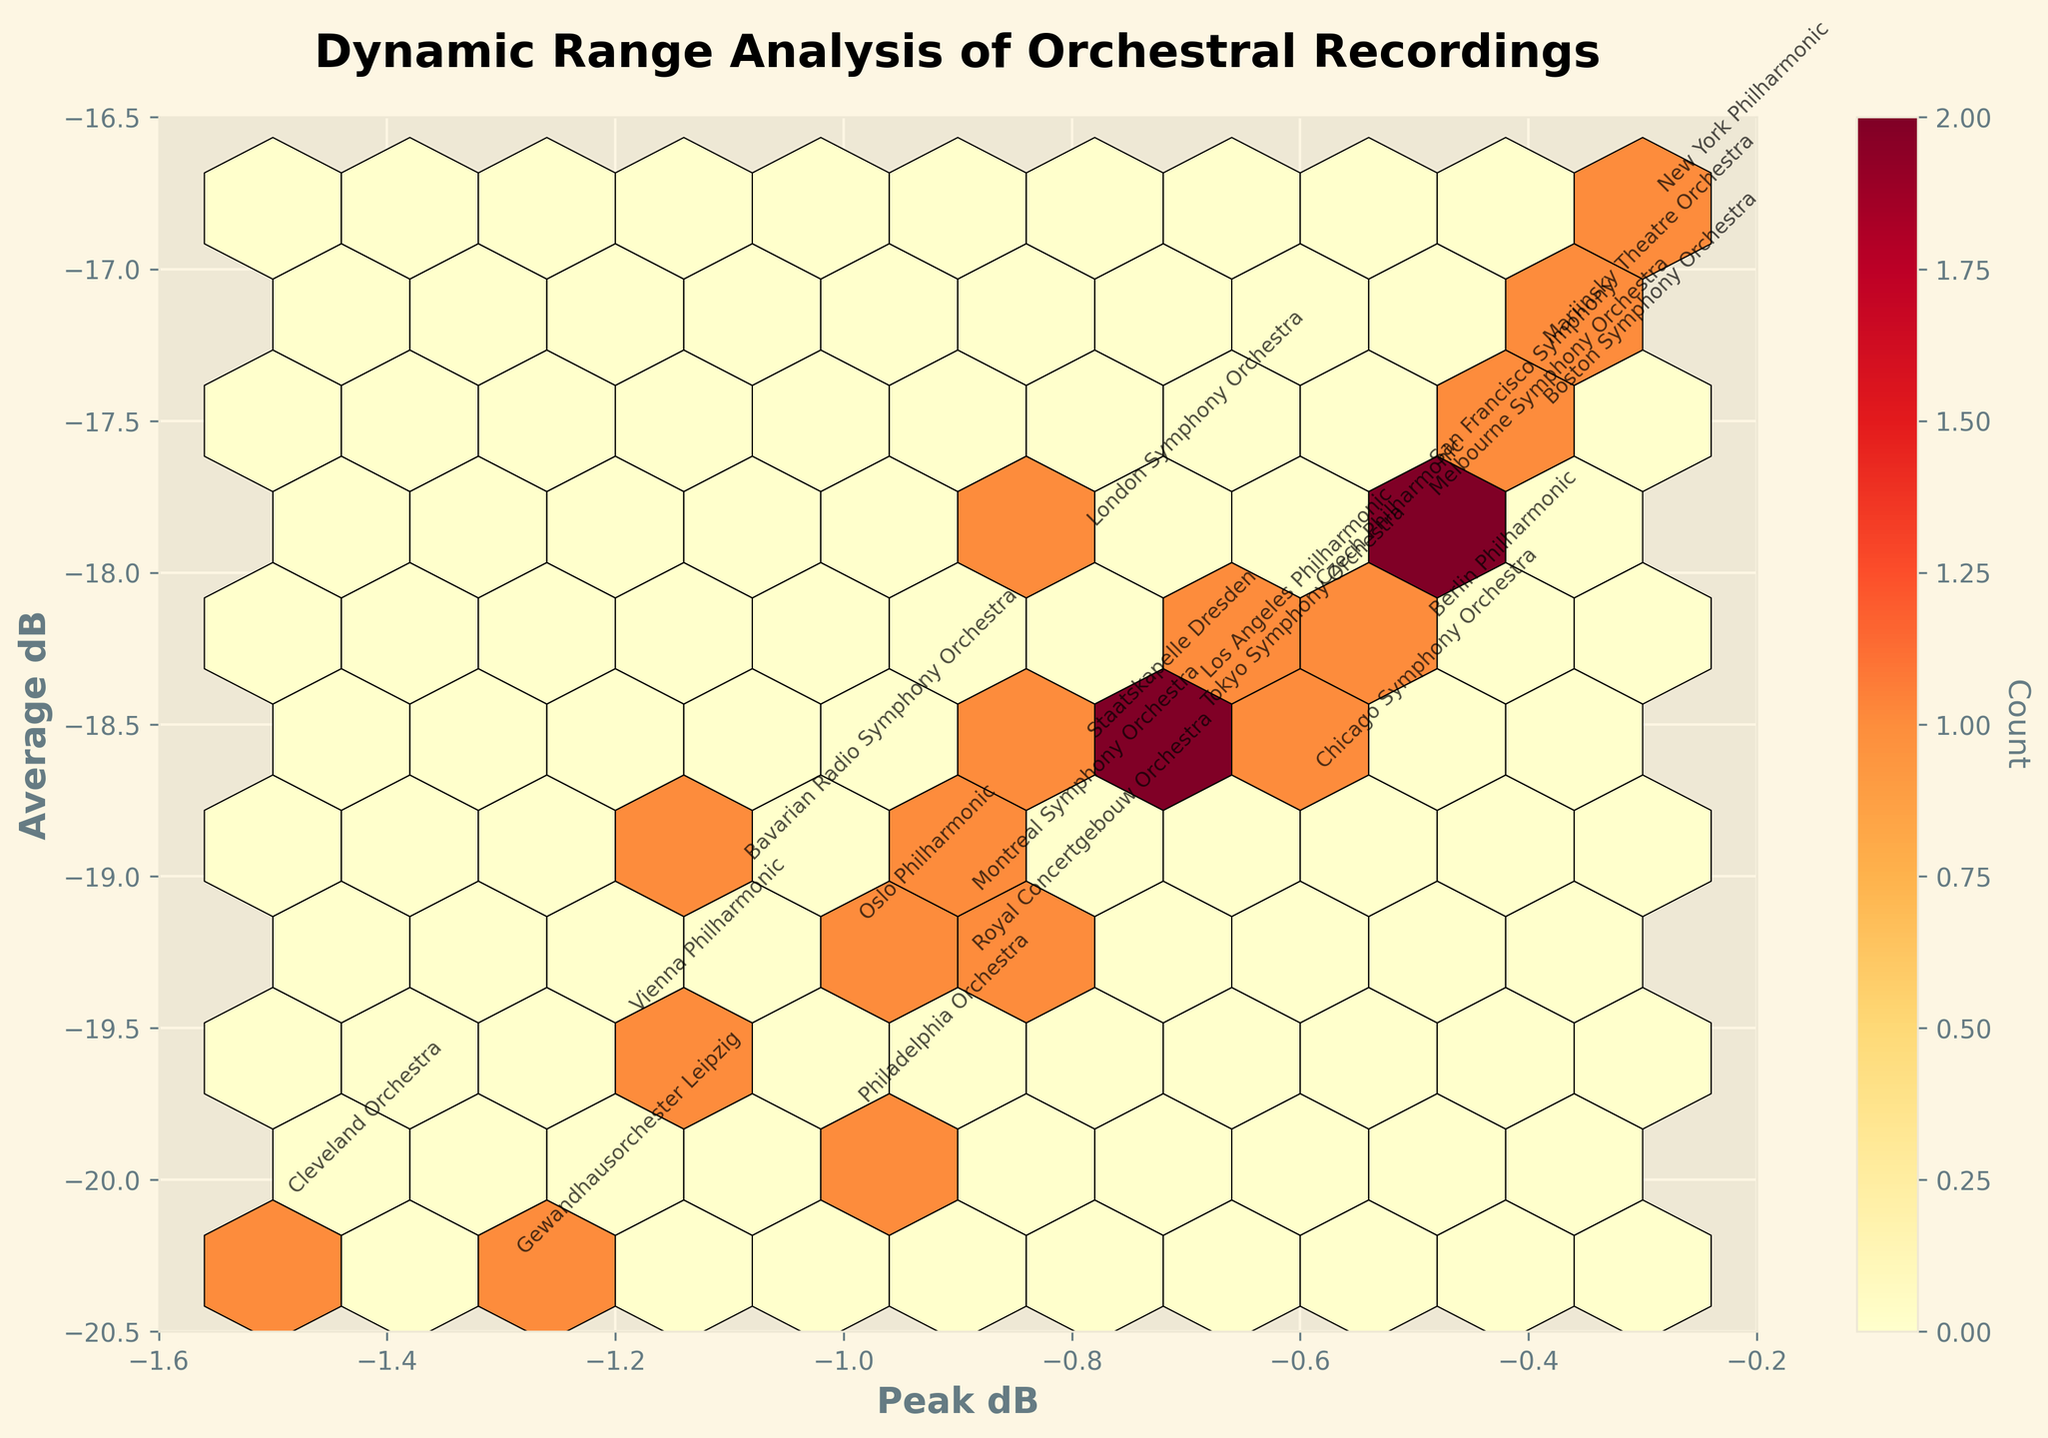What is the title of the Hexbin Plot? The title of the plot is typically located at the top in a larger font size compared to other text elements. It's usually a brief description of what the plot represents.
Answer: Dynamic Range Analysis of Orchestral Recordings What are the x-axis and y-axis labels? Axis labels are located along the horizontal and vertical axes of the plot and provide context for the data being displayed. The x-axis label is usually along the bottom, and the y-axis label is along the left side.
Answer: The x-axis label is 'Peak dB', and the y-axis label is 'Average dB' Which orchestra has the lowest Peak dB value? By examining the plot, you look for the data point that is farthest to the left, indicating the lowest Peak dB value. The orchestra name is typically annotated close to the data point.
Answer: Cleveland Orchestra What is the color range indicative of on this Hexbin Plot? Hexagon color in a Hexbin Plot generally represents the density of data points within that bin. By observing the color gradient and its corresponding color bar, you can interpret the density ranges.
Answer: It indicates the count of data points in each bin How many hexagons have the highest color intensity and what does this intensity represent? By examining the plotted hexagons and cross-referencing the most intense colors with the color bar, you can count the number of hexagons that share this intensity. Higher intensity colors typically represent higher data densities.
Answer: The number of hexagons and this intensity represent the highest density of data points being relatively rare, most likely 1 Which orchestra has the highest Average dB reading? By examining the plot and looking for the data point closest to the top of the y-axis, you can identify the orchestra name annotated near it.
Answer: New York Philharmonic Compare the Peak dB values of the Berlin Philharmonic and the Boston Symphony Orchestra. Which one has a higher value? Locate both orchestras on the plot by their annotations and compare their positions along the x-axis. The one lying more to the right has a higher Peak dB value.
Answer: Berlin Philharmonic What is the midpoint (mean) value of the Average dB readings of the Vienna Philharmonic and the Cleveland Orchestra? Identify and sum the Average dB values of both orchestras. Then, divide the total by 2 to obtain the mean value.
Answer: (19.5 + 20.1) / 2 = 19.8 Are the Peak dB values distributed uniformly across the plotted range? Observing the Hexbin Plot, you can infer the uniformity based on whether the data points fill the plot in a balanced way or if they cluster in specific regions.
Answer: No, they tend to cluster around certain values Which two orchestras fall closest to the average values for both Peak dB and Average dB? First, find the average of the Peak dB and Average dB values across all orchestras. Then, determine which two orchestras' coordinates (Peak dB, Average dB) are nearest to these averages.
Answer: There are several steps involved: calculate the average Peak dB and Average dB, plot these averages, and find the closest points. For simplicity, possible answers could involve orchestras like Royal Concertgebouw Orchestra and Bavarian Radio Symphony Orchestra 